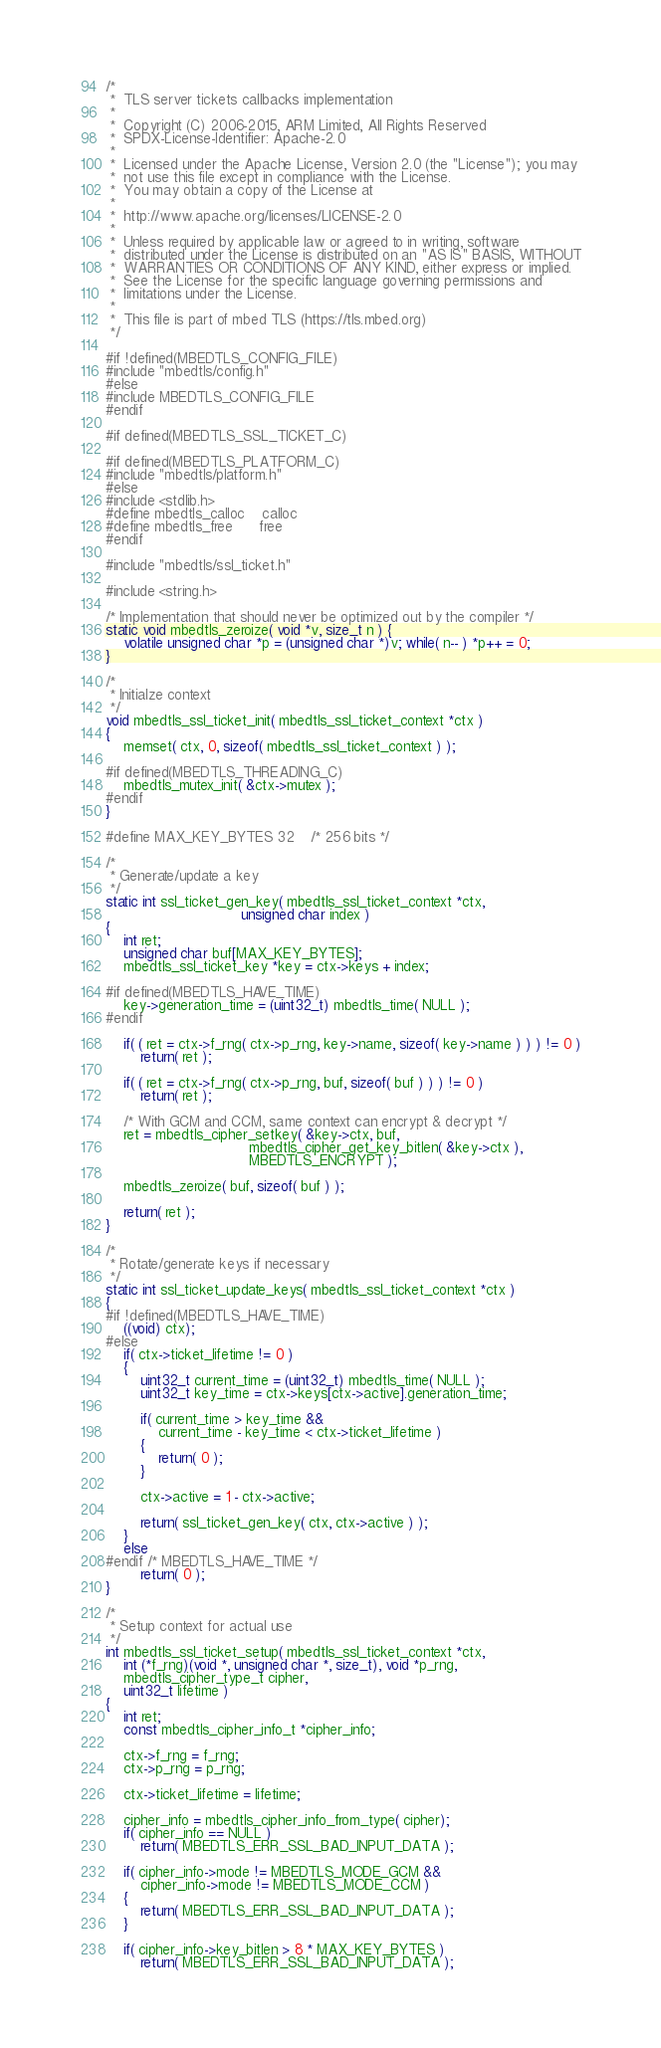Convert code to text. <code><loc_0><loc_0><loc_500><loc_500><_C++_>/*
 *  TLS server tickets callbacks implementation
 *
 *  Copyright (C) 2006-2015, ARM Limited, All Rights Reserved
 *  SPDX-License-Identifier: Apache-2.0
 *
 *  Licensed under the Apache License, Version 2.0 (the "License"); you may
 *  not use this file except in compliance with the License.
 *  You may obtain a copy of the License at
 *
 *  http://www.apache.org/licenses/LICENSE-2.0
 *
 *  Unless required by applicable law or agreed to in writing, software
 *  distributed under the License is distributed on an "AS IS" BASIS, WITHOUT
 *  WARRANTIES OR CONDITIONS OF ANY KIND, either express or implied.
 *  See the License for the specific language governing permissions and
 *  limitations under the License.
 *
 *  This file is part of mbed TLS (https://tls.mbed.org)
 */

#if !defined(MBEDTLS_CONFIG_FILE)
#include "mbedtls/config.h"
#else
#include MBEDTLS_CONFIG_FILE
#endif

#if defined(MBEDTLS_SSL_TICKET_C)

#if defined(MBEDTLS_PLATFORM_C)
#include "mbedtls/platform.h"
#else
#include <stdlib.h>
#define mbedtls_calloc    calloc
#define mbedtls_free      free
#endif

#include "mbedtls/ssl_ticket.h"

#include <string.h>

/* Implementation that should never be optimized out by the compiler */
static void mbedtls_zeroize( void *v, size_t n ) {
    volatile unsigned char *p = (unsigned char *)v; while( n-- ) *p++ = 0;
}

/*
 * Initialze context
 */
void mbedtls_ssl_ticket_init( mbedtls_ssl_ticket_context *ctx )
{
    memset( ctx, 0, sizeof( mbedtls_ssl_ticket_context ) );

#if defined(MBEDTLS_THREADING_C)
    mbedtls_mutex_init( &ctx->mutex );
#endif
}

#define MAX_KEY_BYTES 32    /* 256 bits */

/*
 * Generate/update a key
 */
static int ssl_ticket_gen_key( mbedtls_ssl_ticket_context *ctx,
                               unsigned char index )
{
    int ret;
    unsigned char buf[MAX_KEY_BYTES];
    mbedtls_ssl_ticket_key *key = ctx->keys + index;

#if defined(MBEDTLS_HAVE_TIME)
    key->generation_time = (uint32_t) mbedtls_time( NULL );
#endif

    if( ( ret = ctx->f_rng( ctx->p_rng, key->name, sizeof( key->name ) ) ) != 0 )
        return( ret );

    if( ( ret = ctx->f_rng( ctx->p_rng, buf, sizeof( buf ) ) ) != 0 )
        return( ret );

    /* With GCM and CCM, same context can encrypt & decrypt */
    ret = mbedtls_cipher_setkey( &key->ctx, buf,
                                 mbedtls_cipher_get_key_bitlen( &key->ctx ),
                                 MBEDTLS_ENCRYPT );

    mbedtls_zeroize( buf, sizeof( buf ) );

    return( ret );
}

/*
 * Rotate/generate keys if necessary
 */
static int ssl_ticket_update_keys( mbedtls_ssl_ticket_context *ctx )
{
#if !defined(MBEDTLS_HAVE_TIME)
    ((void) ctx);
#else
    if( ctx->ticket_lifetime != 0 )
    {
        uint32_t current_time = (uint32_t) mbedtls_time( NULL );
        uint32_t key_time = ctx->keys[ctx->active].generation_time;

        if( current_time > key_time &&
            current_time - key_time < ctx->ticket_lifetime )
        {
            return( 0 );
        }

        ctx->active = 1 - ctx->active;

        return( ssl_ticket_gen_key( ctx, ctx->active ) );
    }
    else
#endif /* MBEDTLS_HAVE_TIME */
        return( 0 );
}

/*
 * Setup context for actual use
 */
int mbedtls_ssl_ticket_setup( mbedtls_ssl_ticket_context *ctx,
    int (*f_rng)(void *, unsigned char *, size_t), void *p_rng,
    mbedtls_cipher_type_t cipher,
    uint32_t lifetime )
{
    int ret;
    const mbedtls_cipher_info_t *cipher_info;

    ctx->f_rng = f_rng;
    ctx->p_rng = p_rng;

    ctx->ticket_lifetime = lifetime;

    cipher_info = mbedtls_cipher_info_from_type( cipher);
    if( cipher_info == NULL )
        return( MBEDTLS_ERR_SSL_BAD_INPUT_DATA );

    if( cipher_info->mode != MBEDTLS_MODE_GCM &&
        cipher_info->mode != MBEDTLS_MODE_CCM )
    {
        return( MBEDTLS_ERR_SSL_BAD_INPUT_DATA );
    }

    if( cipher_info->key_bitlen > 8 * MAX_KEY_BYTES )
        return( MBEDTLS_ERR_SSL_BAD_INPUT_DATA );
</code> 